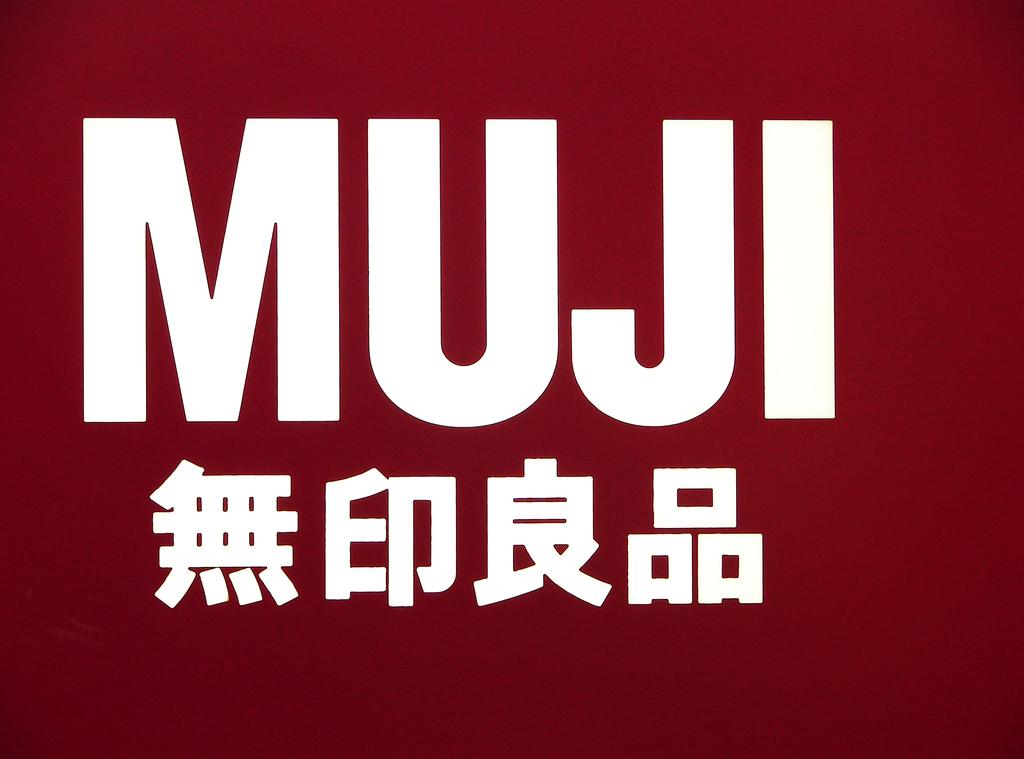What is the name of the website?
Provide a short and direct response. Muji. What do the chinese characters stand for ?
Provide a short and direct response. Muji. 